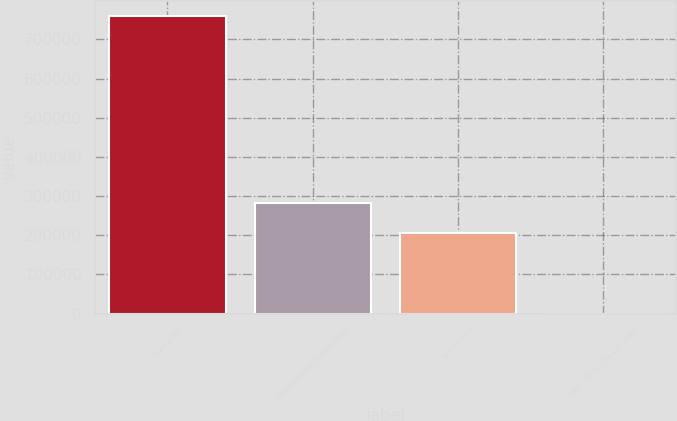Convert chart. <chart><loc_0><loc_0><loc_500><loc_500><bar_chart><fcel>Gross profit<fcel>Income before income taxes<fcel>Net income<fcel>Basic net income per share<nl><fcel>759065<fcel>281149<fcel>205243<fcel>0.35<nl></chart> 